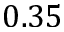<formula> <loc_0><loc_0><loc_500><loc_500>0 . 3 5</formula> 